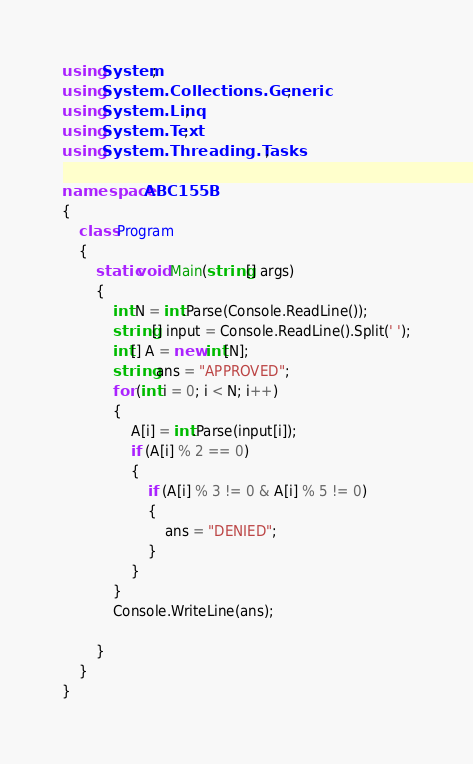Convert code to text. <code><loc_0><loc_0><loc_500><loc_500><_C#_>using System;
using System.Collections.Generic;
using System.Linq;
using System.Text;
using System.Threading.Tasks;

namespace ABC155B
{
    class Program
    {
        static void Main(string[] args)
        {
            int N = int.Parse(Console.ReadLine());
            string[] input = Console.ReadLine().Split(' ');
            int[] A = new int[N];
            string ans = "APPROVED";
            for (int i = 0; i < N; i++)
            {
                A[i] = int.Parse(input[i]);
                if (A[i] % 2 == 0)
                {
                    if (A[i] % 3 != 0 & A[i] % 5 != 0)
                    {
                        ans = "DENIED";
                    }
                }
            }
            Console.WriteLine(ans);

        }
    }
}
</code> 